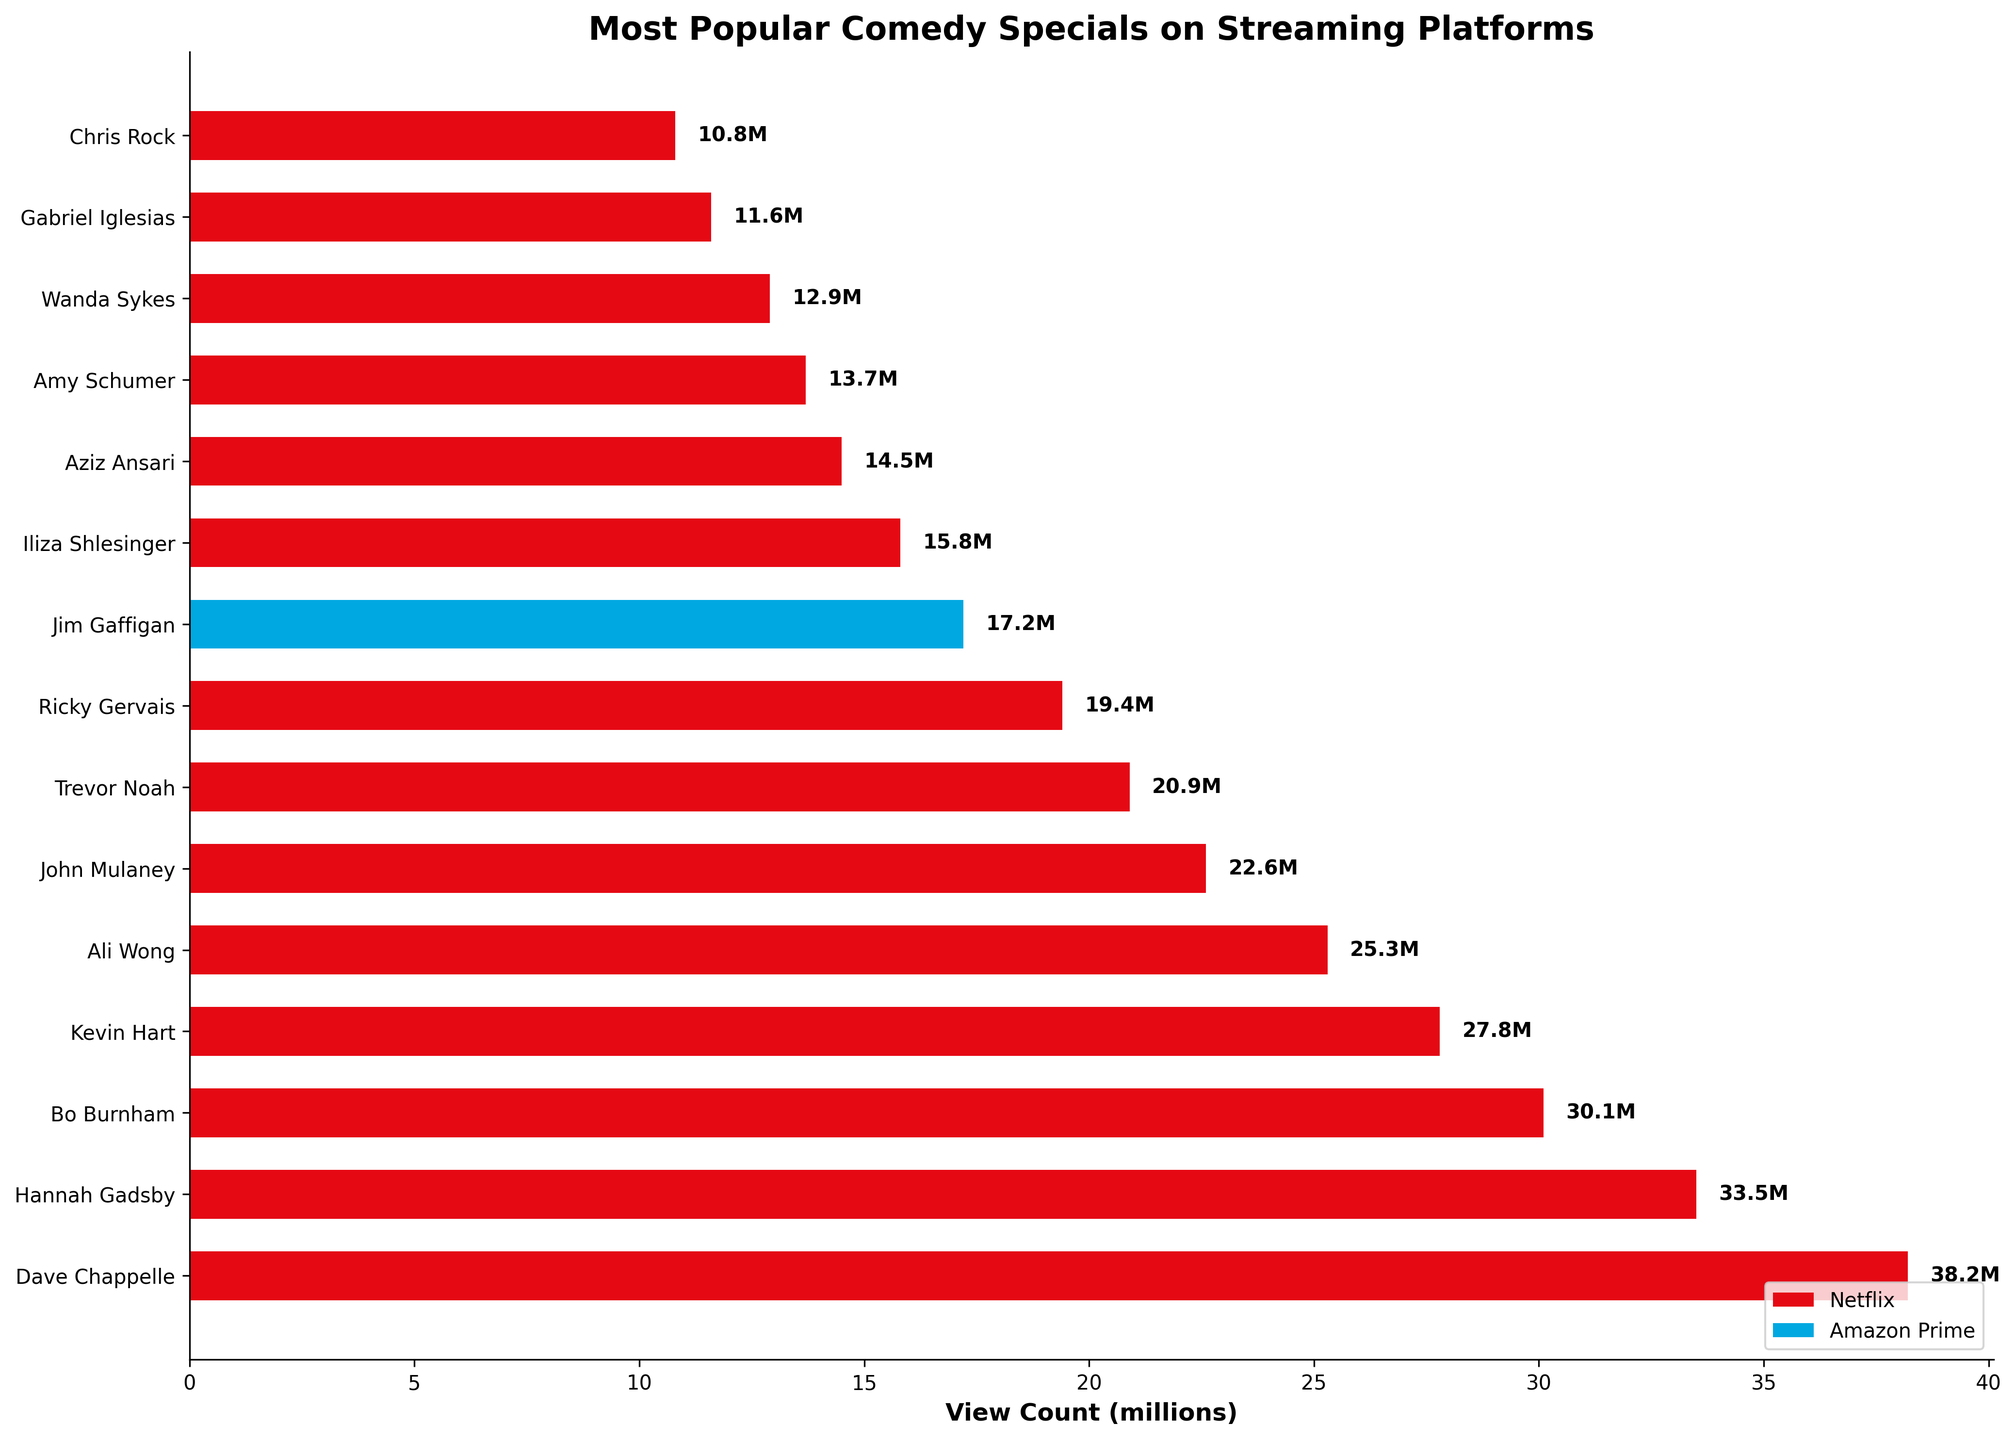How many of the comedy specials have a view count greater than 20 million? Count all the bars with values greater than 20 million. There are 7 comedy specials: Dave Chappelle: Sticks & Stones, Hannah Gadsby: Nanette, Bo Burnham: Inside, Kevin Hart: Zero F**ks Given, Ali Wong: Baby Cobra, John Mulaney: Kid Gorgeous at Radio City, Trevor Noah: Son of Patricia.
Answer: 7 Which comedy special has the highest view count? Look for the bar that is the longest, representing the highest view count. Dave Chappelle: Sticks & Stones is the longest bar.
Answer: Dave Chappelle: Sticks & Stones What is the total view count for all Netflix specials combined? Sum the view counts of all the Netflix specials: 38.2 + 33.5 + 30.1 + 27.8 + 25.3 + 22.6 + 20.9 + 19.4 + 15.8 + 14.5 + 13.7 + 12.9 + 11.6 + 10.8 = 287.1 million.
Answer: 287.1 million Which platform has more entries in the top list, Netflix or Amazon Prime? Count the number of bars for each color representing different platforms. Netflix has 14 entries, and Amazon Prime has 1.
Answer: Netflix What is the difference in view count between the top two specials? Subtract the view count of the second highest special from the highest: 38.2 million (Dave Chappelle: Sticks & Stones) - 33.5 million (Hannah Gadsby: Nanette) = 4.7 million.
Answer: 4.7 million What is the average view count of the top 5 comedy specials? Sum the view counts of the top 5 bars and divide by 5: (38.2 + 33.5 + 30.1 + 27.8 + 25.3) / 5 = 154.9 / 5 = 30.98 million.
Answer: 30.98 million Which comedy special on Amazon Prime is included in the chart? Identify the single bar that is colored differently (presumably not red). The special is Jim Gaffigan: Quality Time.
Answer: Jim Gaffigan: Quality Time Are there more comedy specials with a view count below 15 million or above it? Count the bars to the left and right of the 15-million mark. There are 5 specials below 15 million and 10 specials above.
Answer: Above 15 million How much more popular is the highest viewed special compared to the least viewed one? Subtract the view count of the least viewed special, Chris Rock: Tamborine (10.8 million), from the highest viewed special, Dave Chappelle: Sticks & Stones (38.2 million): 38.2 - 10.8 = 27.4 million.
Answer: 27.4 million 